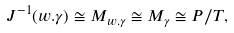<formula> <loc_0><loc_0><loc_500><loc_500>J ^ { - 1 } ( w . \gamma ) \cong M _ { w . \gamma } \cong M _ { \gamma } \cong P / T ,</formula> 